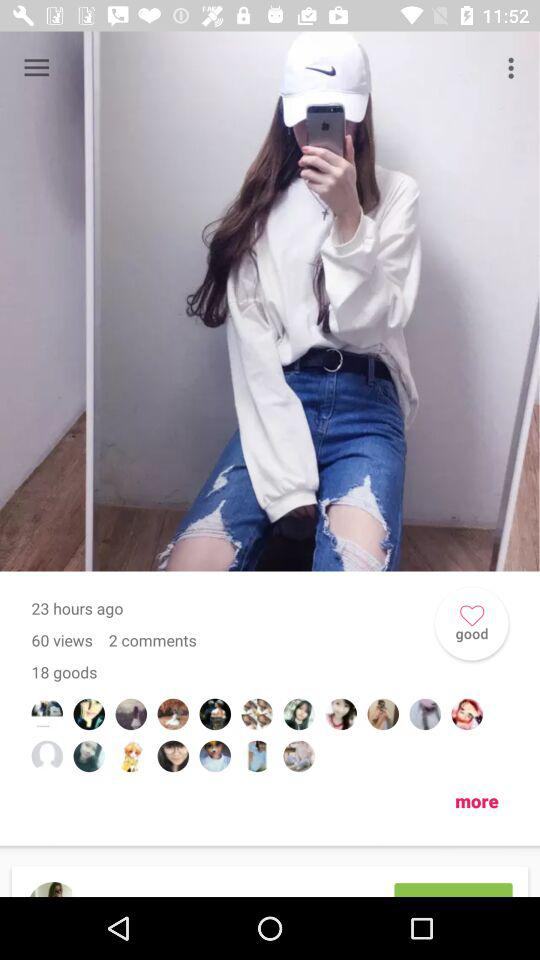How many comments are there? There are 2 comments. 